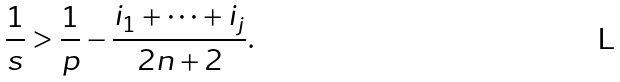Convert formula to latex. <formula><loc_0><loc_0><loc_500><loc_500>\frac { 1 } { s } > \frac { 1 } { p } - \frac { i _ { 1 } + \cdots + i _ { j } } { 2 n + 2 } .</formula> 